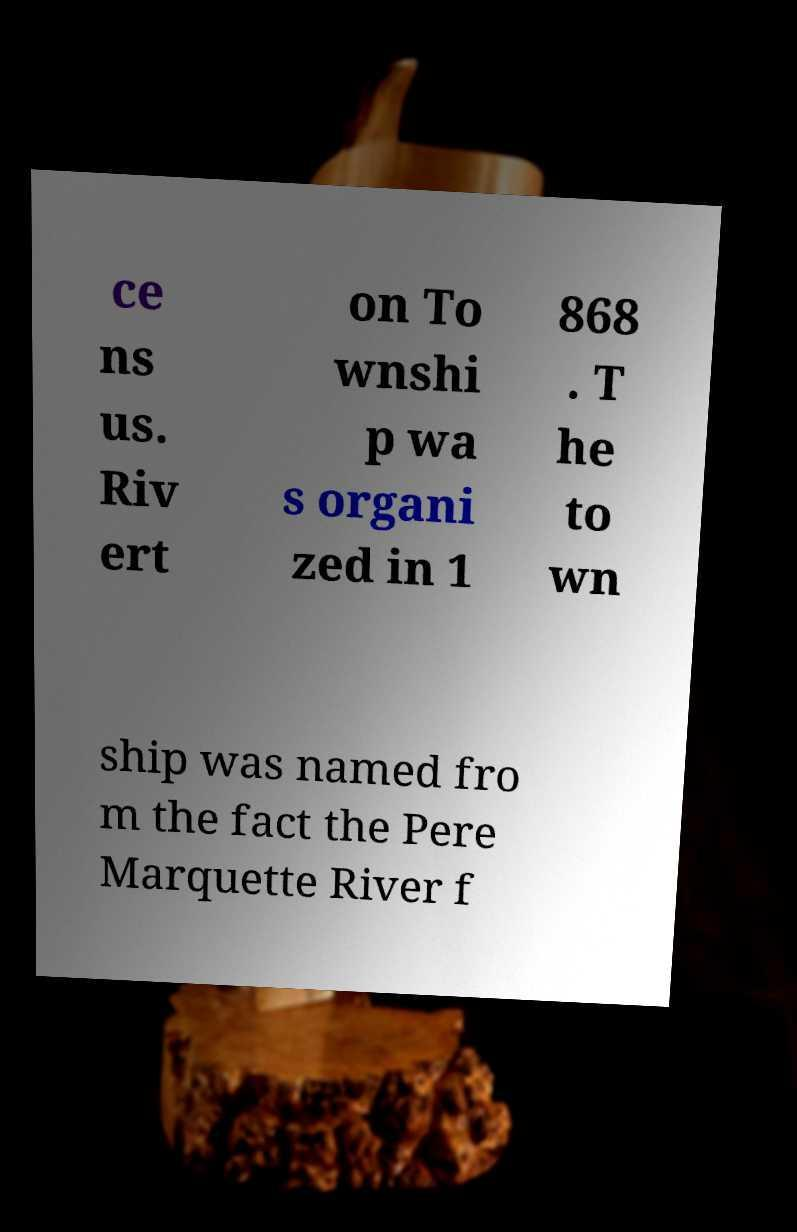Can you accurately transcribe the text from the provided image for me? ce ns us. Riv ert on To wnshi p wa s organi zed in 1 868 . T he to wn ship was named fro m the fact the Pere Marquette River f 